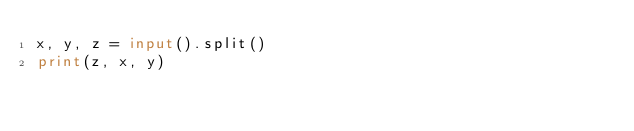Convert code to text. <code><loc_0><loc_0><loc_500><loc_500><_Python_>x, y, z = input().split()
print(z, x, y)
</code> 